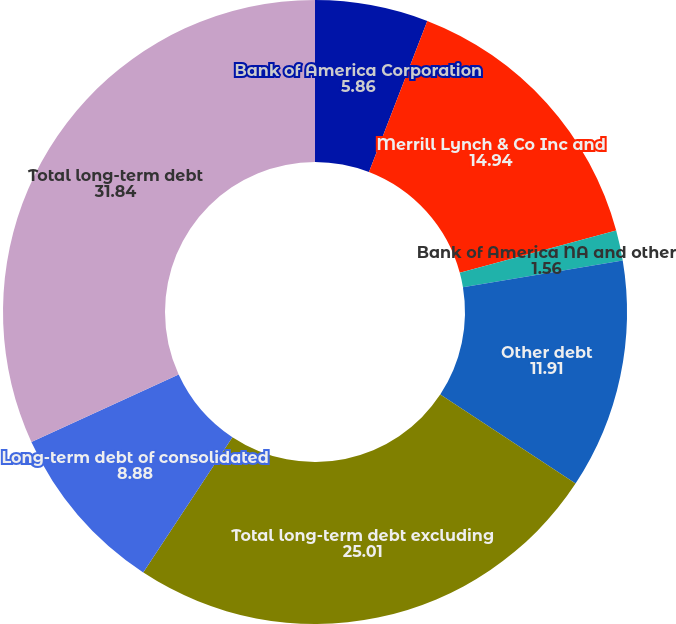Convert chart. <chart><loc_0><loc_0><loc_500><loc_500><pie_chart><fcel>Bank of America Corporation<fcel>Merrill Lynch & Co Inc and<fcel>Bank of America NA and other<fcel>Other debt<fcel>Total long-term debt excluding<fcel>Long-term debt of consolidated<fcel>Total long-term debt<nl><fcel>5.86%<fcel>14.94%<fcel>1.56%<fcel>11.91%<fcel>25.01%<fcel>8.88%<fcel>31.84%<nl></chart> 